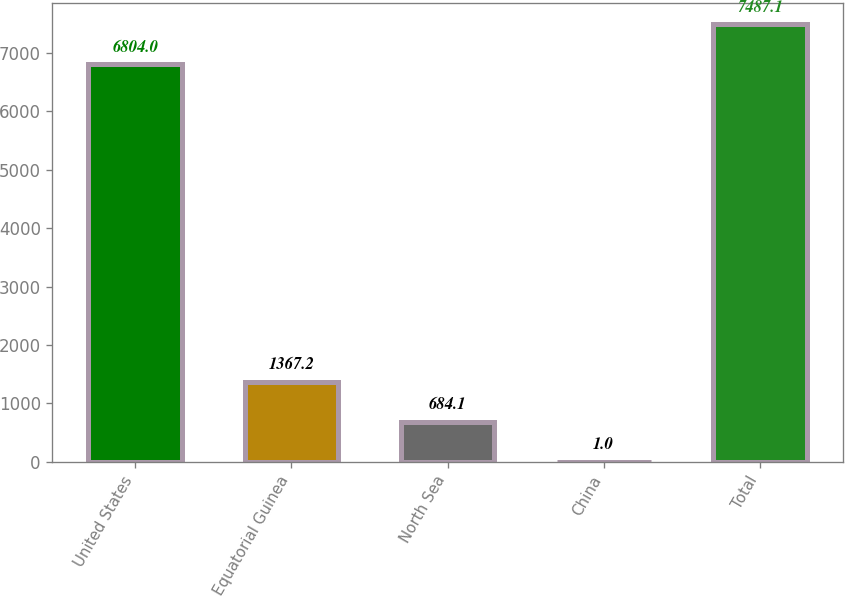<chart> <loc_0><loc_0><loc_500><loc_500><bar_chart><fcel>United States<fcel>Equatorial Guinea<fcel>North Sea<fcel>China<fcel>Total<nl><fcel>6804<fcel>1367.2<fcel>684.1<fcel>1<fcel>7487.1<nl></chart> 